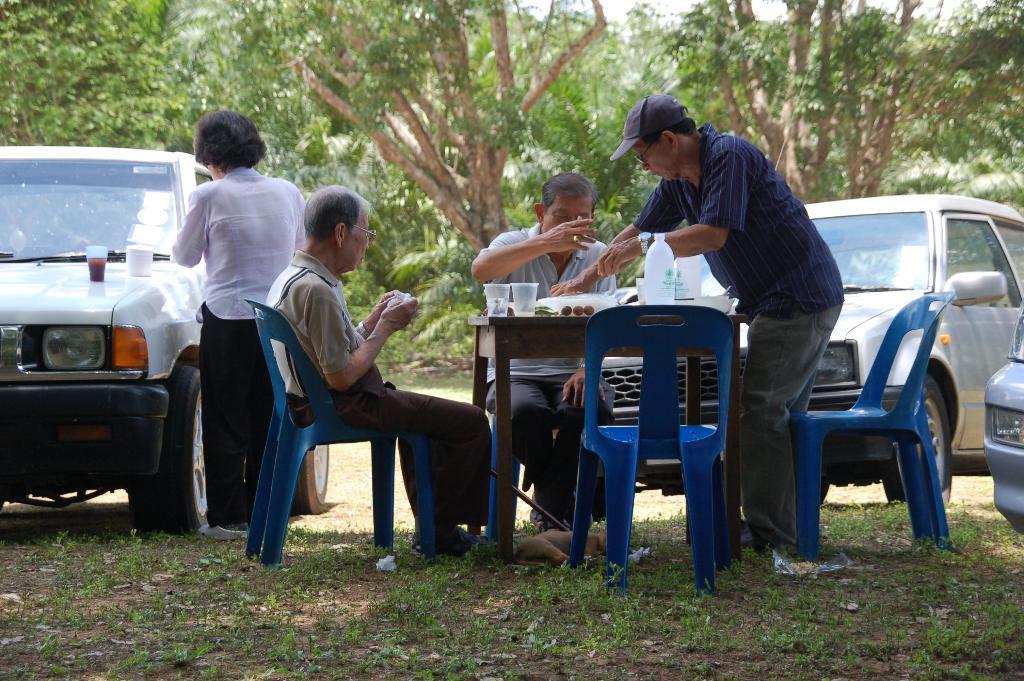Describe this image in one or two sentences. In the middle of the image few people are sitting, standing and there are some chairs and table, on the table we can see some bottles and glasses. Behind them we can see some vehicles. At the top of the image there are some trees. At the bottom of the image there is grass. 